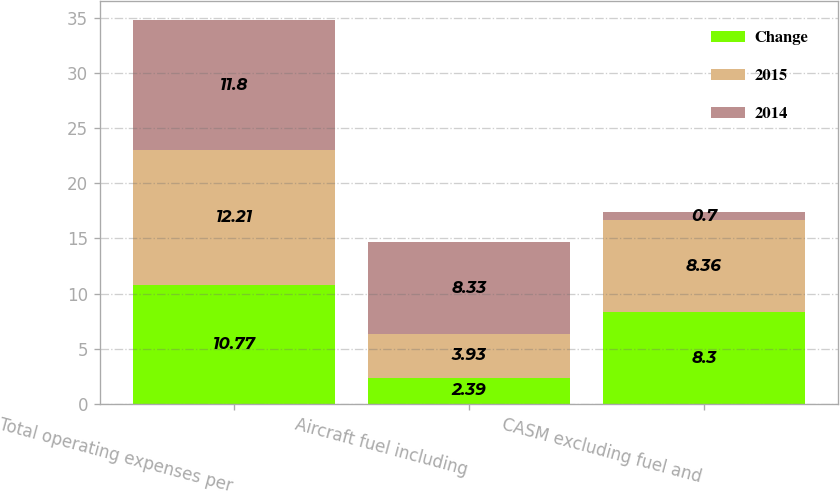<chart> <loc_0><loc_0><loc_500><loc_500><stacked_bar_chart><ecel><fcel>Total operating expenses per<fcel>Aircraft fuel including<fcel>CASM excluding fuel and<nl><fcel>Change<fcel>10.77<fcel>2.39<fcel>8.3<nl><fcel>2015<fcel>12.21<fcel>3.93<fcel>8.36<nl><fcel>2014<fcel>11.8<fcel>8.33<fcel>0.7<nl></chart> 